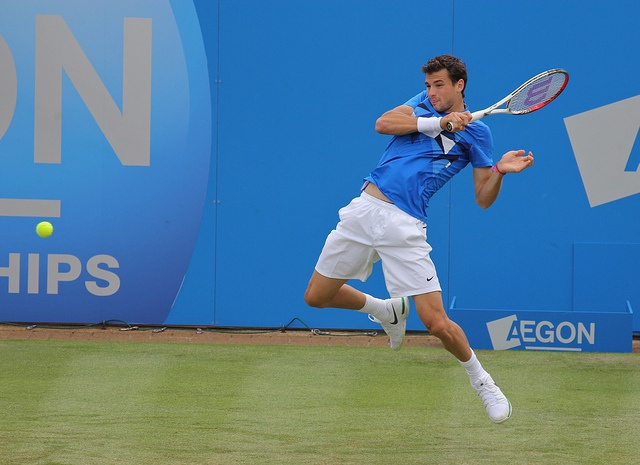Describe the objects in this image and their specific colors. I can see people in darkgray, lavender, blue, and brown tones, tennis racket in darkgray, gray, and lightgray tones, and sports ball in darkgray, yellow, khaki, and olive tones in this image. 